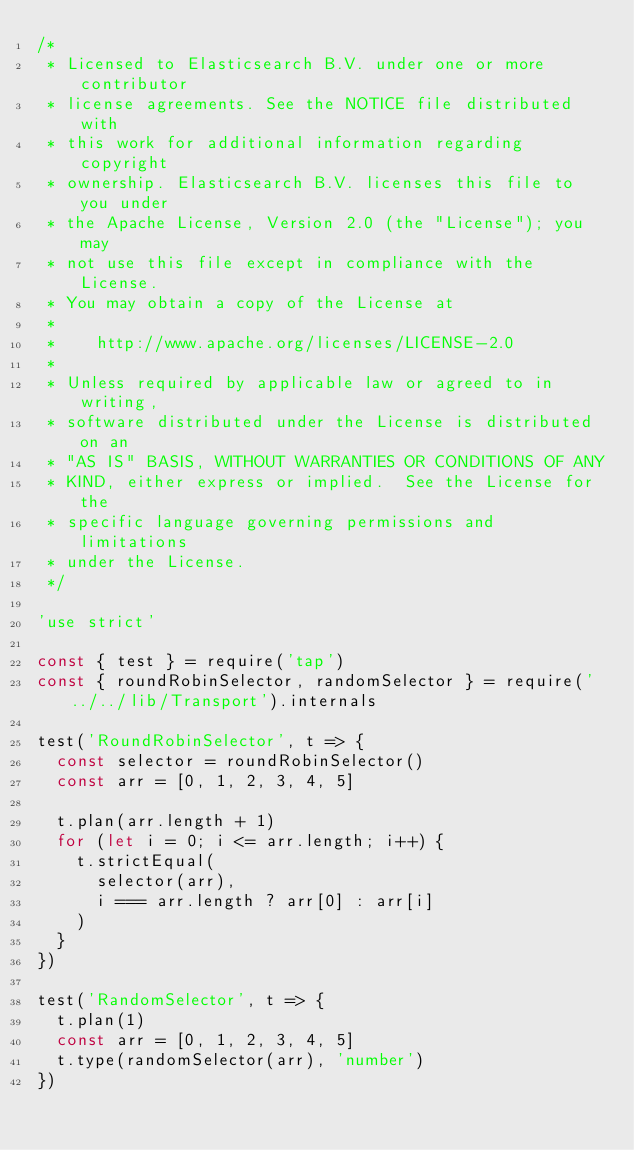<code> <loc_0><loc_0><loc_500><loc_500><_JavaScript_>/*
 * Licensed to Elasticsearch B.V. under one or more contributor
 * license agreements. See the NOTICE file distributed with
 * this work for additional information regarding copyright
 * ownership. Elasticsearch B.V. licenses this file to you under
 * the Apache License, Version 2.0 (the "License"); you may
 * not use this file except in compliance with the License.
 * You may obtain a copy of the License at
 *
 *    http://www.apache.org/licenses/LICENSE-2.0
 *
 * Unless required by applicable law or agreed to in writing,
 * software distributed under the License is distributed on an
 * "AS IS" BASIS, WITHOUT WARRANTIES OR CONDITIONS OF ANY
 * KIND, either express or implied.  See the License for the
 * specific language governing permissions and limitations
 * under the License.
 */

'use strict'

const { test } = require('tap')
const { roundRobinSelector, randomSelector } = require('../../lib/Transport').internals

test('RoundRobinSelector', t => {
  const selector = roundRobinSelector()
  const arr = [0, 1, 2, 3, 4, 5]

  t.plan(arr.length + 1)
  for (let i = 0; i <= arr.length; i++) {
    t.strictEqual(
      selector(arr),
      i === arr.length ? arr[0] : arr[i]
    )
  }
})

test('RandomSelector', t => {
  t.plan(1)
  const arr = [0, 1, 2, 3, 4, 5]
  t.type(randomSelector(arr), 'number')
})
</code> 